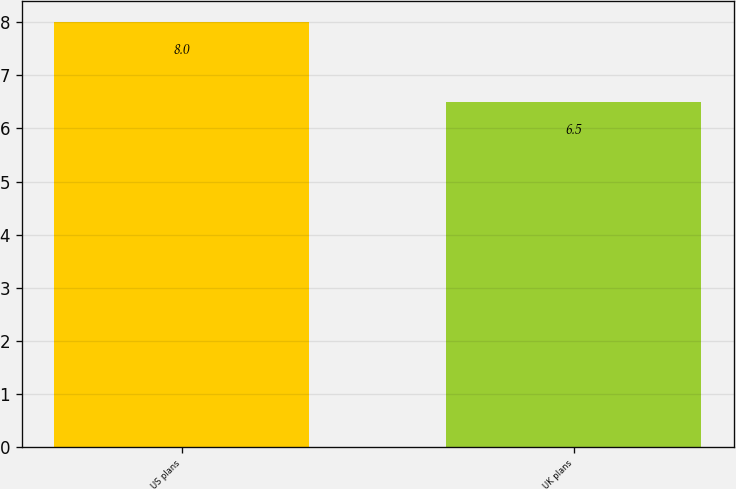Convert chart. <chart><loc_0><loc_0><loc_500><loc_500><bar_chart><fcel>US plans<fcel>UK plans<nl><fcel>8<fcel>6.5<nl></chart> 